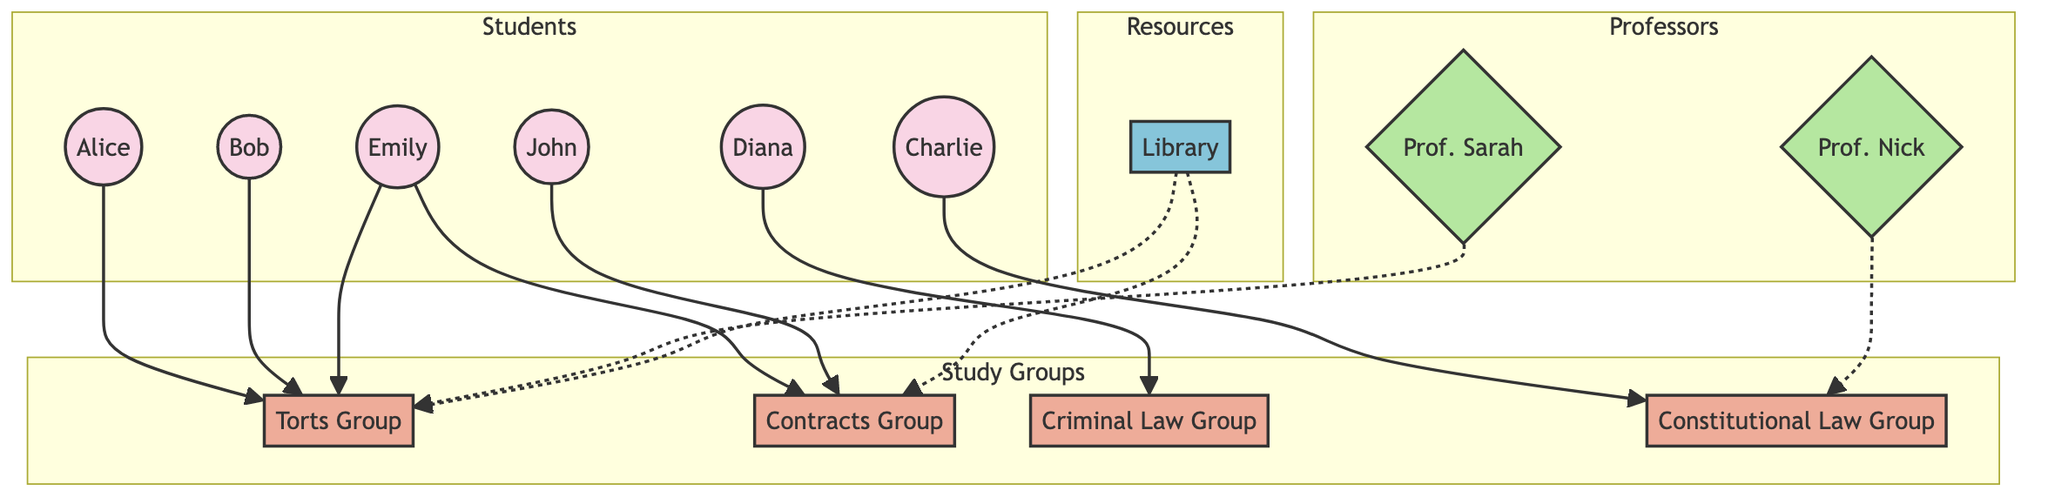What is the total number of students in the diagram? There are six nodes labeled as "Student" in the diagram: Alice, Bob, Charlie, Diana, Emily, and John. Counting these nodes gives a total of six students.
Answer: 6 Which study group is John a member of? Looking at the edges in the diagram, John is connected to the "Contracts Group" as a member. There's no other group linked to John.
Answer: Contracts Group Who advises the Torts Group? The diagram shows an edge that connects Sarah to the Torts Group, indicating that she acts as an advisor to this group.
Answer: Sarah How many study groups are there in total? The diagram features four study groups: Torts Group, Contracts Group, Criminal Law Group, and Constitutional Law Group. Counting these gives a total of four.
Answer: 4 Which library is linked to both the Torts and Contracts groups? The node labeled Luke represents the library which has edges indicating it is a meeting place for both the Torts Group and the Contracts Group.
Answer: Luke Which student is a member of both the Torts Group and another group? Examining the connections, Emily is shown to be a member of both the Torts Group and the Contracts Group. So she fits the criteria of being in two groups.
Answer: Emily How many professors are associated with the study groups? The diagram displays two professors: Nick advises the Constitutional Law Group, and Sarah advises the Torts Group. Hence, there are two professors related to the study groups.
Answer: 2 Which student is part of the Criminal Law Group? According to the edges in the diagram, Diana is connected to the Criminal Law Group, indicating her membership in that group.
Answer: Diana What is the subject of the study group that Charlie belongs to? Charlie is a member of the Constitutional Law Group, as indicated by the edge connecting him to this group in the diagram.
Answer: Constitutional Law 